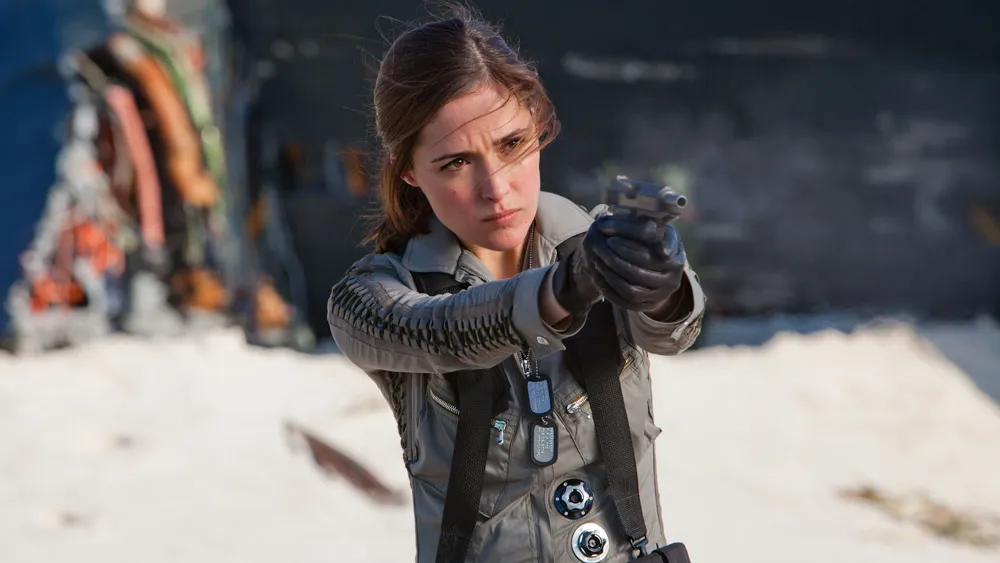Can you describe the emotions conveyed by the actress in this scene? The actress in the image conveys a strong sense of determination and intensity. Her serious expression, with eyes focused and eyebrows slightly narrowed, suggests a readiness to confront a challenging or dangerous situation. The way she grips the gun firmly indicates control and preparedness, reflecting her commitment to facing whatever threat lies ahead. Overall, the emotions conveyed are of bravery, focus, and resolve. How does the setting contribute to the mood of the scene? The setting of the image significantly contributes to the intensity and urgency of the scene. The stark, desolate backdrop with its dark, almost shadowy features contrasts with the actress's determined stance, highlighting the gravity of the situation. It feels like a confrontation is about to happen or is already unfolding, adding a layer of suspense. The minimalistic environment ensures that all attention is drawn to the actress and her actions, amplifying the tension and focus on her readiness to act. Imagine this character’s backstory. What events might have led up to this moment? Imagine this character, a skilled agent or soldier, has a backstory filled with rigorous training and tough missions. Her journey could have begun as a young recruit with a natural talent for strategy and combat, quickly rising through the ranks due to her exceptional abilities. Along the way, she might have faced personal loss, such as the death of a close mentor or teammate, driving her to become even more resolute and focused. The current scene could be set during a critical mission, perhaps to thwart a significant threat or rescue a valuable ally, where every moment counts. Her past experiences have shaped her into a formidable character who stands unwavering in the face of danger, ready to overcome any obstacle. 